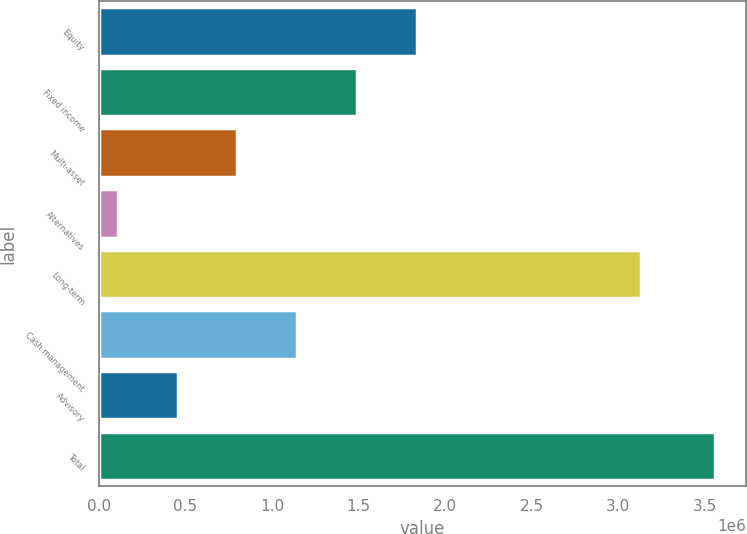Convert chart. <chart><loc_0><loc_0><loc_500><loc_500><bar_chart><fcel>Equity<fcel>Fixed income<fcel>Multi-asset<fcel>Alternatives<fcel>Long-term<fcel>Cash management<fcel>Advisory<fcel>Total<nl><fcel>1.83535e+06<fcel>1.49023e+06<fcel>799984<fcel>109738<fcel>3.13112e+06<fcel>1.14511e+06<fcel>454861<fcel>3.56097e+06<nl></chart> 